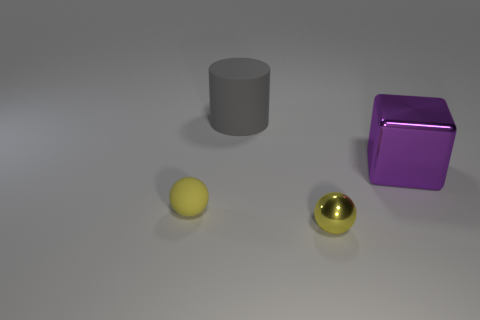Is there anything else that is the same shape as the big gray object?
Provide a succinct answer. No. What is the size of the metal thing that is the same color as the tiny rubber sphere?
Make the answer very short. Small. How many cubes are small red matte things or tiny yellow metallic objects?
Your response must be concise. 0. The metallic ball has what size?
Provide a succinct answer. Small. What number of tiny metal balls are to the right of the large purple thing?
Keep it short and to the point. 0. There is a rubber thing that is on the right side of the sphere left of the metal sphere; what is its size?
Give a very brief answer. Large. Do the metal object in front of the tiny yellow matte ball and the thing that is behind the big shiny cube have the same shape?
Ensure brevity in your answer.  No. The small yellow thing to the right of the rubber thing behind the big purple metallic object is what shape?
Give a very brief answer. Sphere. There is a thing that is both behind the tiny shiny object and in front of the big purple metal block; what size is it?
Offer a very short reply. Small. Do the large purple metal object and the tiny yellow metal thing right of the large rubber thing have the same shape?
Offer a very short reply. No. 